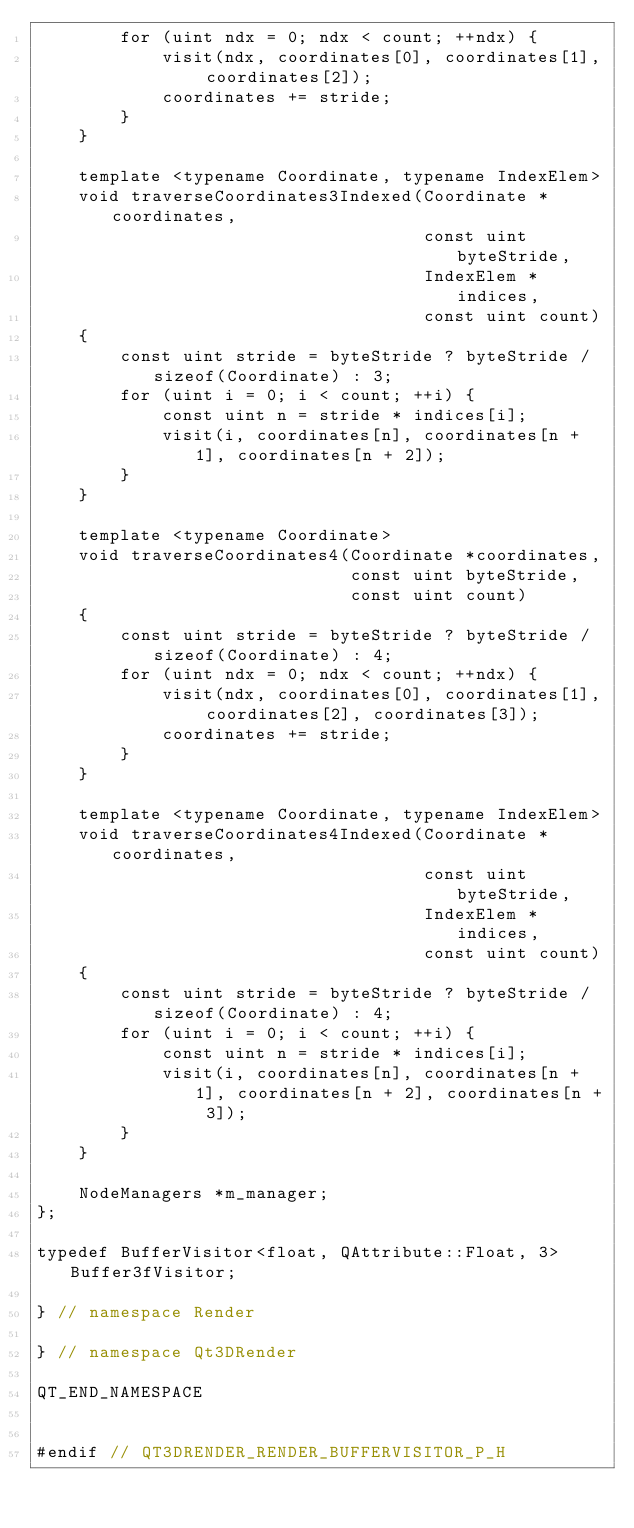<code> <loc_0><loc_0><loc_500><loc_500><_C_>        for (uint ndx = 0; ndx < count; ++ndx) {
            visit(ndx, coordinates[0], coordinates[1], coordinates[2]);
            coordinates += stride;
        }
    }

    template <typename Coordinate, typename IndexElem>
    void traverseCoordinates3Indexed(Coordinate *coordinates,
                                     const uint byteStride,
                                     IndexElem *indices,
                                     const uint count)
    {
        const uint stride = byteStride ? byteStride / sizeof(Coordinate) : 3;
        for (uint i = 0; i < count; ++i) {
            const uint n = stride * indices[i];
            visit(i, coordinates[n], coordinates[n + 1], coordinates[n + 2]);
        }
    }

    template <typename Coordinate>
    void traverseCoordinates4(Coordinate *coordinates,
                              const uint byteStride,
                              const uint count)
    {
        const uint stride = byteStride ? byteStride / sizeof(Coordinate) : 4;
        for (uint ndx = 0; ndx < count; ++ndx) {
            visit(ndx, coordinates[0], coordinates[1], coordinates[2], coordinates[3]);
            coordinates += stride;
        }
    }

    template <typename Coordinate, typename IndexElem>
    void traverseCoordinates4Indexed(Coordinate *coordinates,
                                     const uint byteStride,
                                     IndexElem *indices,
                                     const uint count)
    {
        const uint stride = byteStride ? byteStride / sizeof(Coordinate) : 4;
        for (uint i = 0; i < count; ++i) {
            const uint n = stride * indices[i];
            visit(i, coordinates[n], coordinates[n + 1], coordinates[n + 2], coordinates[n + 3]);
        }
    }

    NodeManagers *m_manager;
};

typedef BufferVisitor<float, QAttribute::Float, 3> Buffer3fVisitor;

} // namespace Render

} // namespace Qt3DRender

QT_END_NAMESPACE


#endif // QT3DRENDER_RENDER_BUFFERVISITOR_P_H
</code> 